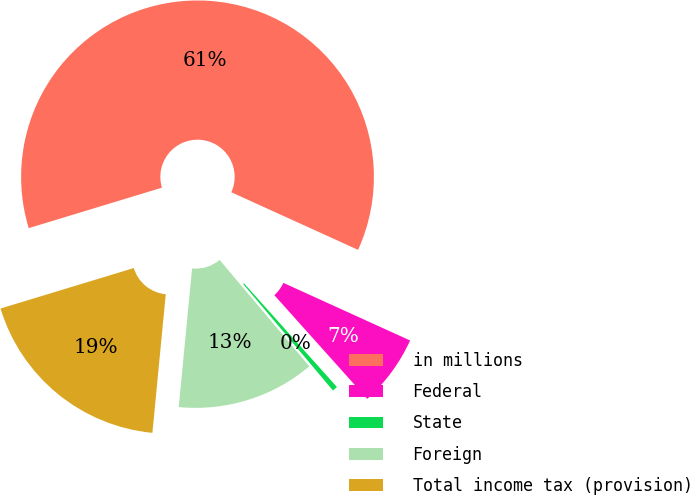Convert chart. <chart><loc_0><loc_0><loc_500><loc_500><pie_chart><fcel>in millions<fcel>Federal<fcel>State<fcel>Foreign<fcel>Total income tax (provision)<nl><fcel>61.49%<fcel>6.58%<fcel>0.48%<fcel>12.68%<fcel>18.78%<nl></chart> 